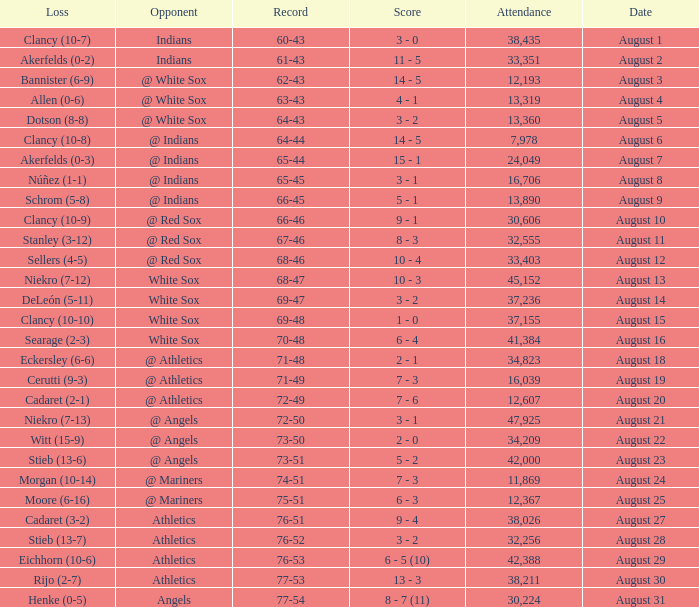What was the attendance when the record was 77-54? 30224.0. 